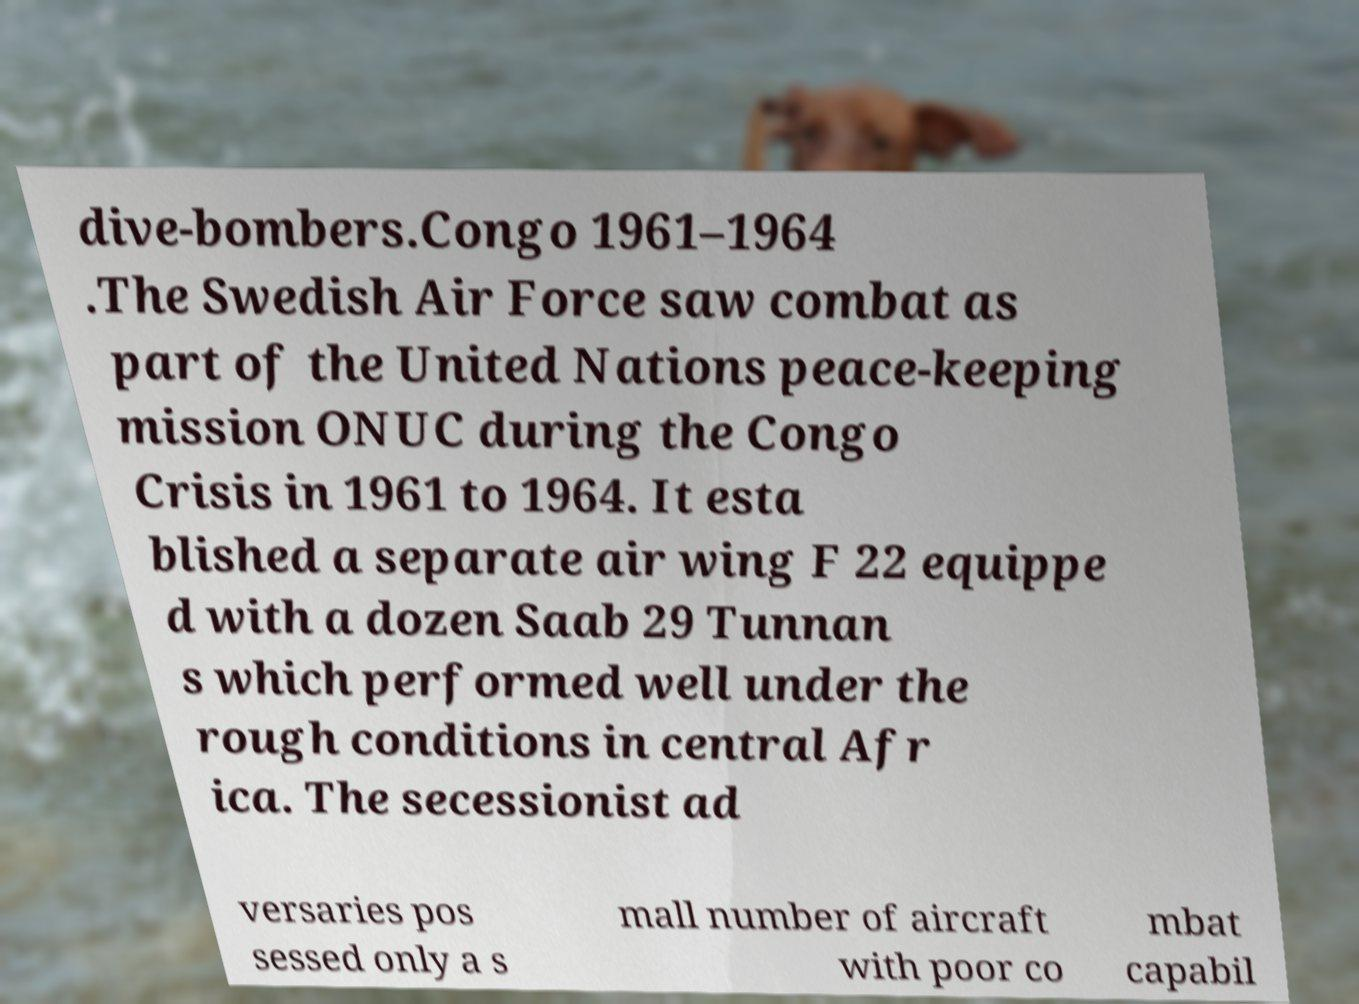Can you accurately transcribe the text from the provided image for me? dive-bombers.Congo 1961–1964 .The Swedish Air Force saw combat as part of the United Nations peace-keeping mission ONUC during the Congo Crisis in 1961 to 1964. It esta blished a separate air wing F 22 equippe d with a dozen Saab 29 Tunnan s which performed well under the rough conditions in central Afr ica. The secessionist ad versaries pos sessed only a s mall number of aircraft with poor co mbat capabil 